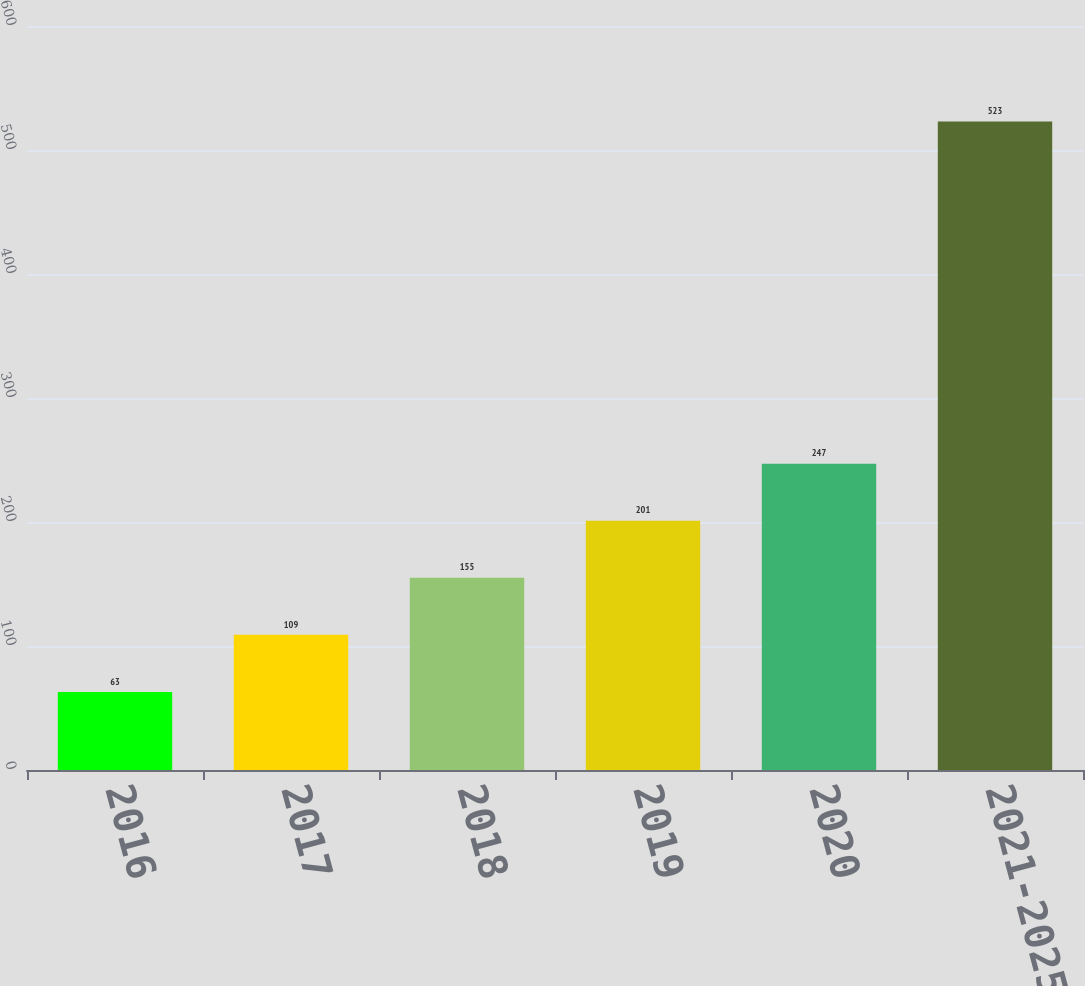Convert chart. <chart><loc_0><loc_0><loc_500><loc_500><bar_chart><fcel>2016<fcel>2017<fcel>2018<fcel>2019<fcel>2020<fcel>2021-2025<nl><fcel>63<fcel>109<fcel>155<fcel>201<fcel>247<fcel>523<nl></chart> 